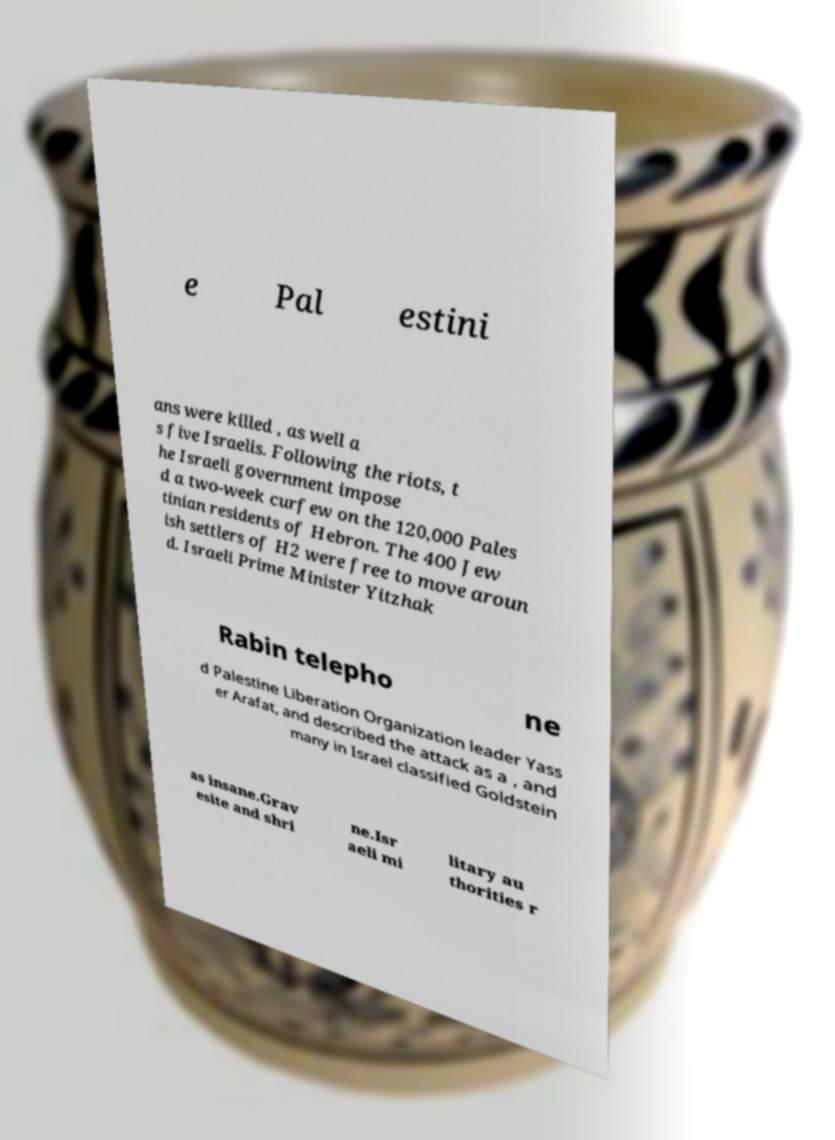Can you read and provide the text displayed in the image?This photo seems to have some interesting text. Can you extract and type it out for me? e Pal estini ans were killed , as well a s five Israelis. Following the riots, t he Israeli government impose d a two-week curfew on the 120,000 Pales tinian residents of Hebron. The 400 Jew ish settlers of H2 were free to move aroun d. Israeli Prime Minister Yitzhak Rabin telepho ne d Palestine Liberation Organization leader Yass er Arafat, and described the attack as a , and many in Israel classified Goldstein as insane.Grav esite and shri ne.Isr aeli mi litary au thorities r 